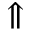Convert formula to latex. <formula><loc_0><loc_0><loc_500><loc_500>\Uparrow</formula> 